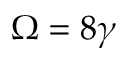<formula> <loc_0><loc_0><loc_500><loc_500>\Omega = 8 \gamma</formula> 